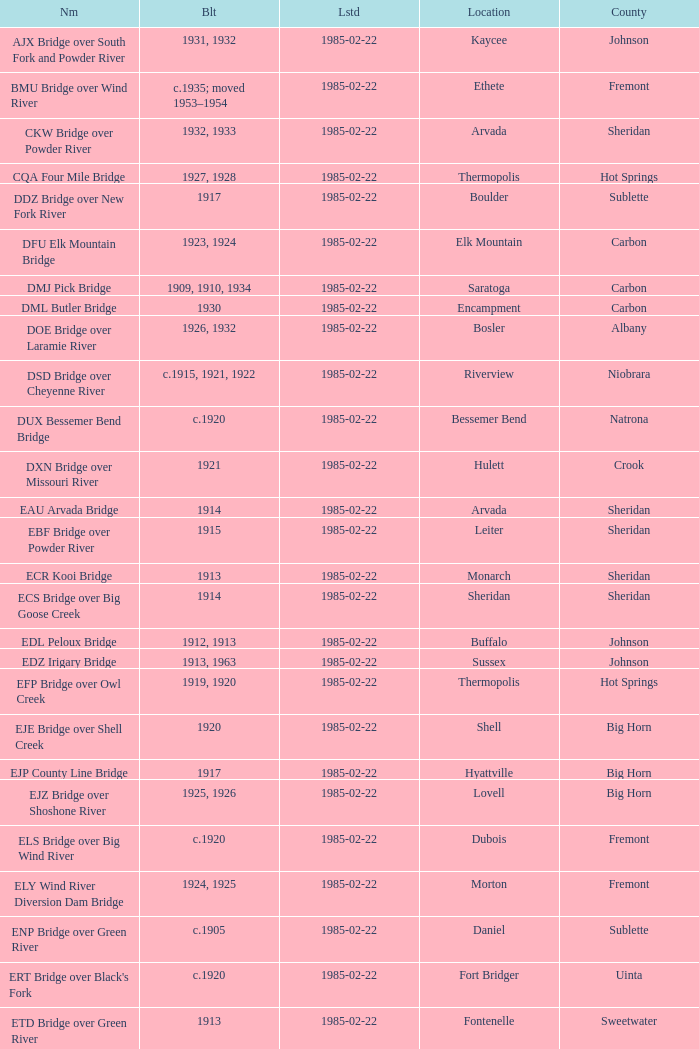In what year was the bridge in Lovell built? 1925, 1926. 